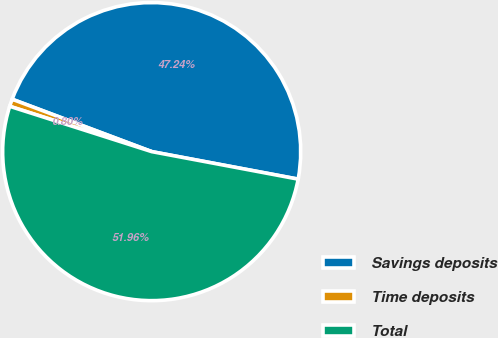Convert chart. <chart><loc_0><loc_0><loc_500><loc_500><pie_chart><fcel>Savings deposits<fcel>Time deposits<fcel>Total<nl><fcel>47.24%<fcel>0.8%<fcel>51.96%<nl></chart> 